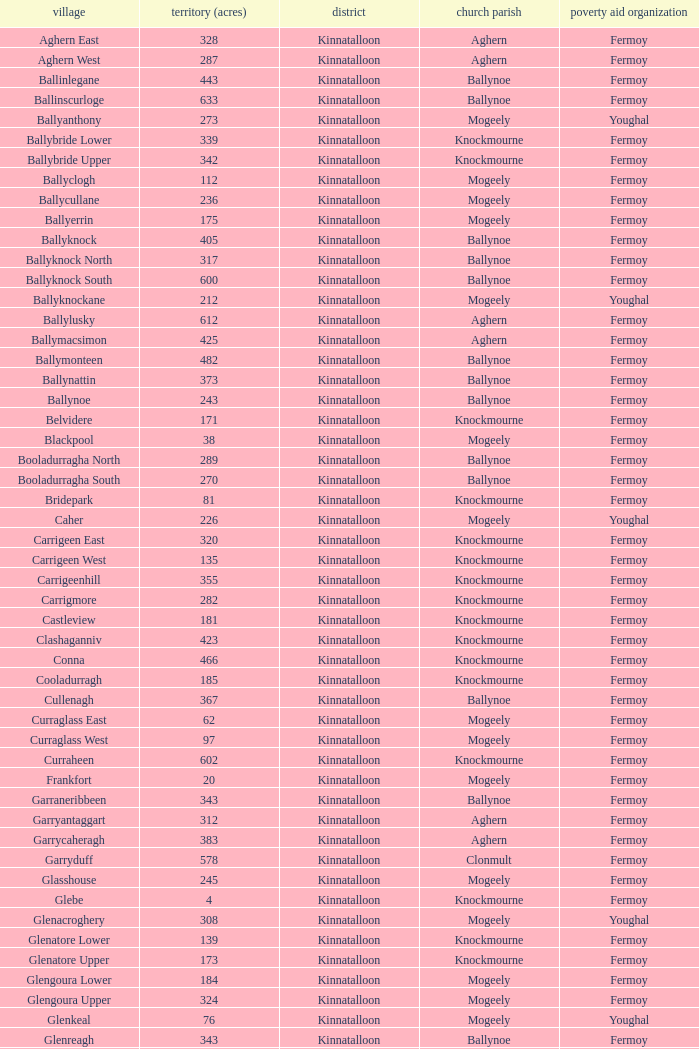Name the area for civil parish ballynoe and killasseragh 340.0. 